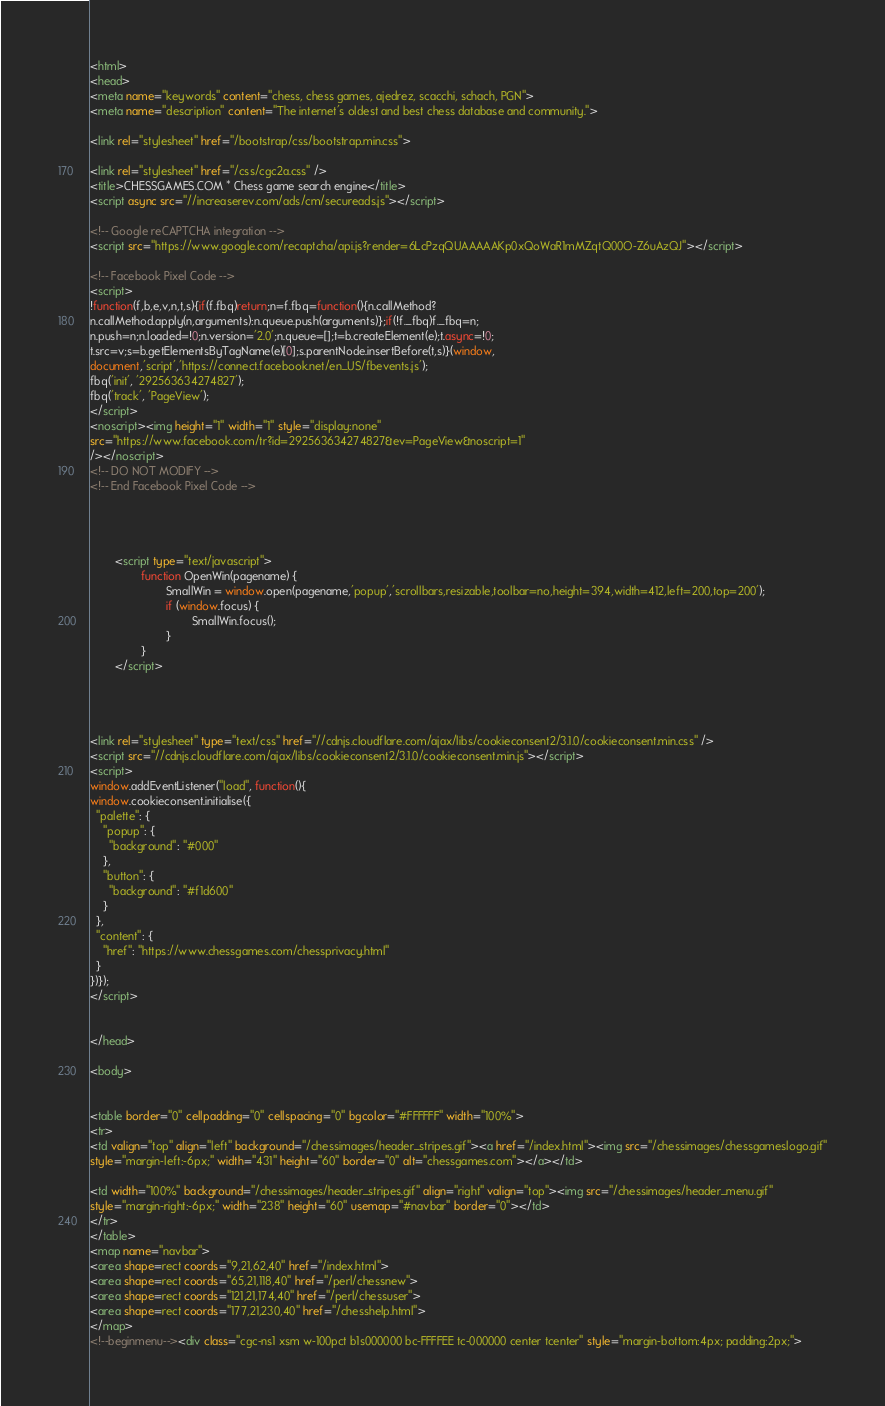<code> <loc_0><loc_0><loc_500><loc_500><_HTML_>
<html>
<head>
<meta name="keywords" content="chess, chess games, ajedrez, scacchi, schach, PGN">
<meta name="description" content="The internet's oldest and best chess database and community.">

<link rel="stylesheet" href="/bootstrap/css/bootstrap.min.css">

<link rel="stylesheet" href="/css/cgc2a.css" />
<title>CHESSGAMES.COM * Chess game search engine</title>
<script async src="//increaserev.com/ads/cm/secureads.js"></script>

<!-- Google reCAPTCHA integration -->
<script src="https://www.google.com/recaptcha/api.js?render=6LcPzqQUAAAAAKp0xQoWaR1mMZqtQ00O-Z6uAzQJ"></script>

<!-- Facebook Pixel Code -->
<script>
!function(f,b,e,v,n,t,s){if(f.fbq)return;n=f.fbq=function(){n.callMethod?
n.callMethod.apply(n,arguments):n.queue.push(arguments)};if(!f._fbq)f._fbq=n;
n.push=n;n.loaded=!0;n.version='2.0';n.queue=[];t=b.createElement(e);t.async=!0;
t.src=v;s=b.getElementsByTagName(e)[0];s.parentNode.insertBefore(t,s)}(window,
document,'script','https://connect.facebook.net/en_US/fbevents.js');
fbq('init', '292563634274827');
fbq('track', 'PageView');
</script>
<noscript><img height="1" width="1" style="display:none"
src="https://www.facebook.com/tr?id=292563634274827&ev=PageView&noscript=1"
/></noscript>
<!-- DO NOT MODIFY -->
<!-- End Facebook Pixel Code -->




		<script type="text/javascript">
                function OpenWin(pagename) {
                        SmallWin = window.open(pagename,'popup','scrollbars,resizable,toolbar=no,height=394,width=412,left=200,top=200');
                        if (window.focus) {
                                SmallWin.focus();
                        }
                }
		</script>




<link rel="stylesheet" type="text/css" href="//cdnjs.cloudflare.com/ajax/libs/cookieconsent2/3.1.0/cookieconsent.min.css" />
<script src="//cdnjs.cloudflare.com/ajax/libs/cookieconsent2/3.1.0/cookieconsent.min.js"></script>
<script>
window.addEventListener("load", function(){
window.cookieconsent.initialise({
  "palette": {
    "popup": {
      "background": "#000"
    },
    "button": {
      "background": "#f1d600"
    }
  },
  "content": {
    "href": "https://www.chessgames.com/chessprivacy.html"
  }
})});
</script>


</head>

<body>


<table border="0" cellpadding="0" cellspacing="0" bgcolor="#FFFFFF" width="100%">
<tr>
<td valign="top" align="left" background="/chessimages/header_stripes.gif"><a href="/index.html"><img src="/chessimages/chessgameslogo.gif"
style="margin-left:-6px;" width="431" height="60" border="0" alt="chessgames.com"></a></td>

<td width="100%" background="/chessimages/header_stripes.gif" align="right" valign="top"><img src="/chessimages/header_menu.gif"
style="margin-right:-6px;" width="238" height="60" usemap="#navbar" border="0"></td>
</tr>
</table>
<map name="navbar">
<area shape=rect coords="9,21,62,40" href="/index.html">
<area shape=rect coords="65,21,118,40" href="/perl/chessnew">
<area shape=rect coords="121,21,174,40" href="/perl/chessuser">
<area shape=rect coords="177,21,230,40" href="/chesshelp.html">
</map>
<!--beginmenu--><div class="cgc-ns1 xsm w-100pct b1s000000 bc-FFFFEE tc-000000 center tcenter" style="margin-bottom:4px; padding:2px;"></code> 